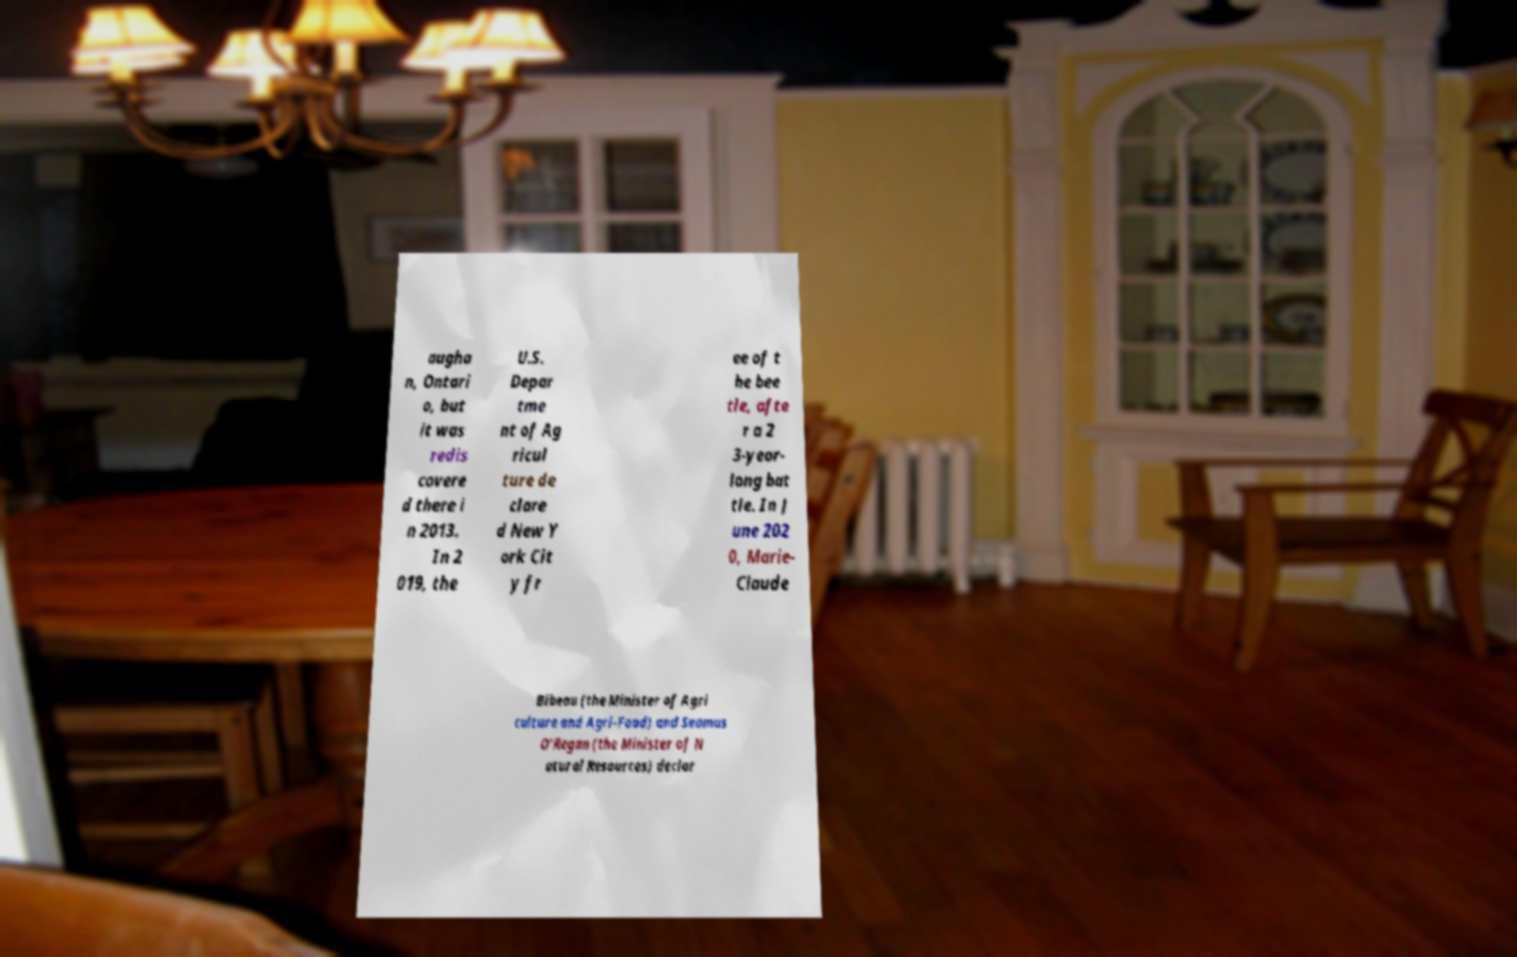There's text embedded in this image that I need extracted. Can you transcribe it verbatim? augha n, Ontari o, but it was redis covere d there i n 2013. In 2 019, the U.S. Depar tme nt of Ag ricul ture de clare d New Y ork Cit y fr ee of t he bee tle, afte r a 2 3-year- long bat tle. In J une 202 0, Marie- Claude Bibeau (the Minister of Agri culture and Agri-Food) and Seamus O'Regan (the Minister of N atural Resources) declar 